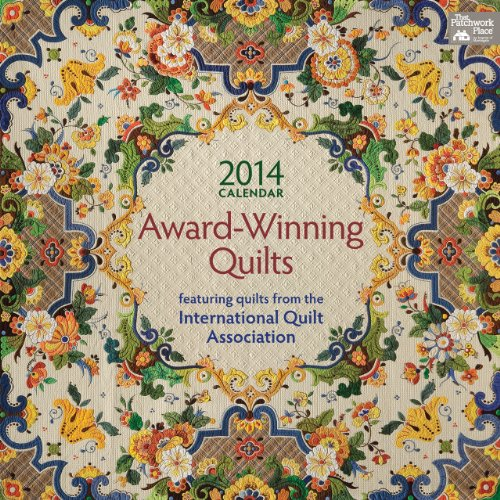Who is the author of this book? The book is likely published by That Patchwork Place, a known publisher in the quilting community. However, the actual creator might be the various quilt artists featured in the calendar. 